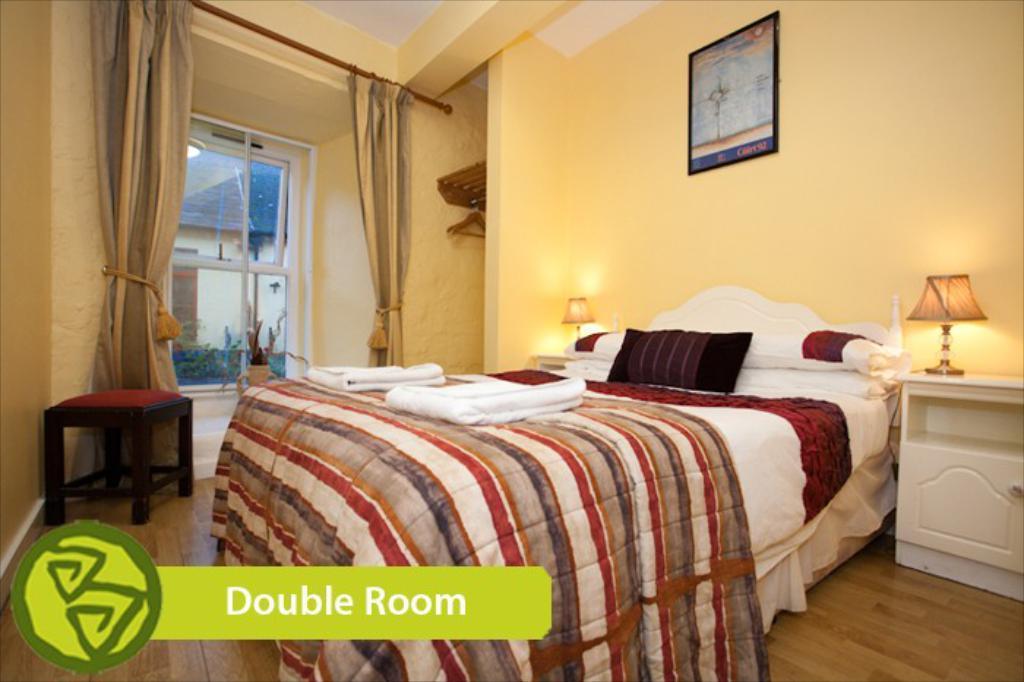Describe this image in one or two sentences. The image is taken in the room. In the center of the image there is a bed and we can see cushions placed on the bed. On the right there is a stand and we can see a lamp placed on the stand. On the left there is a stool. In the background there are curtains and a window. There is a frame placed on the wall. 